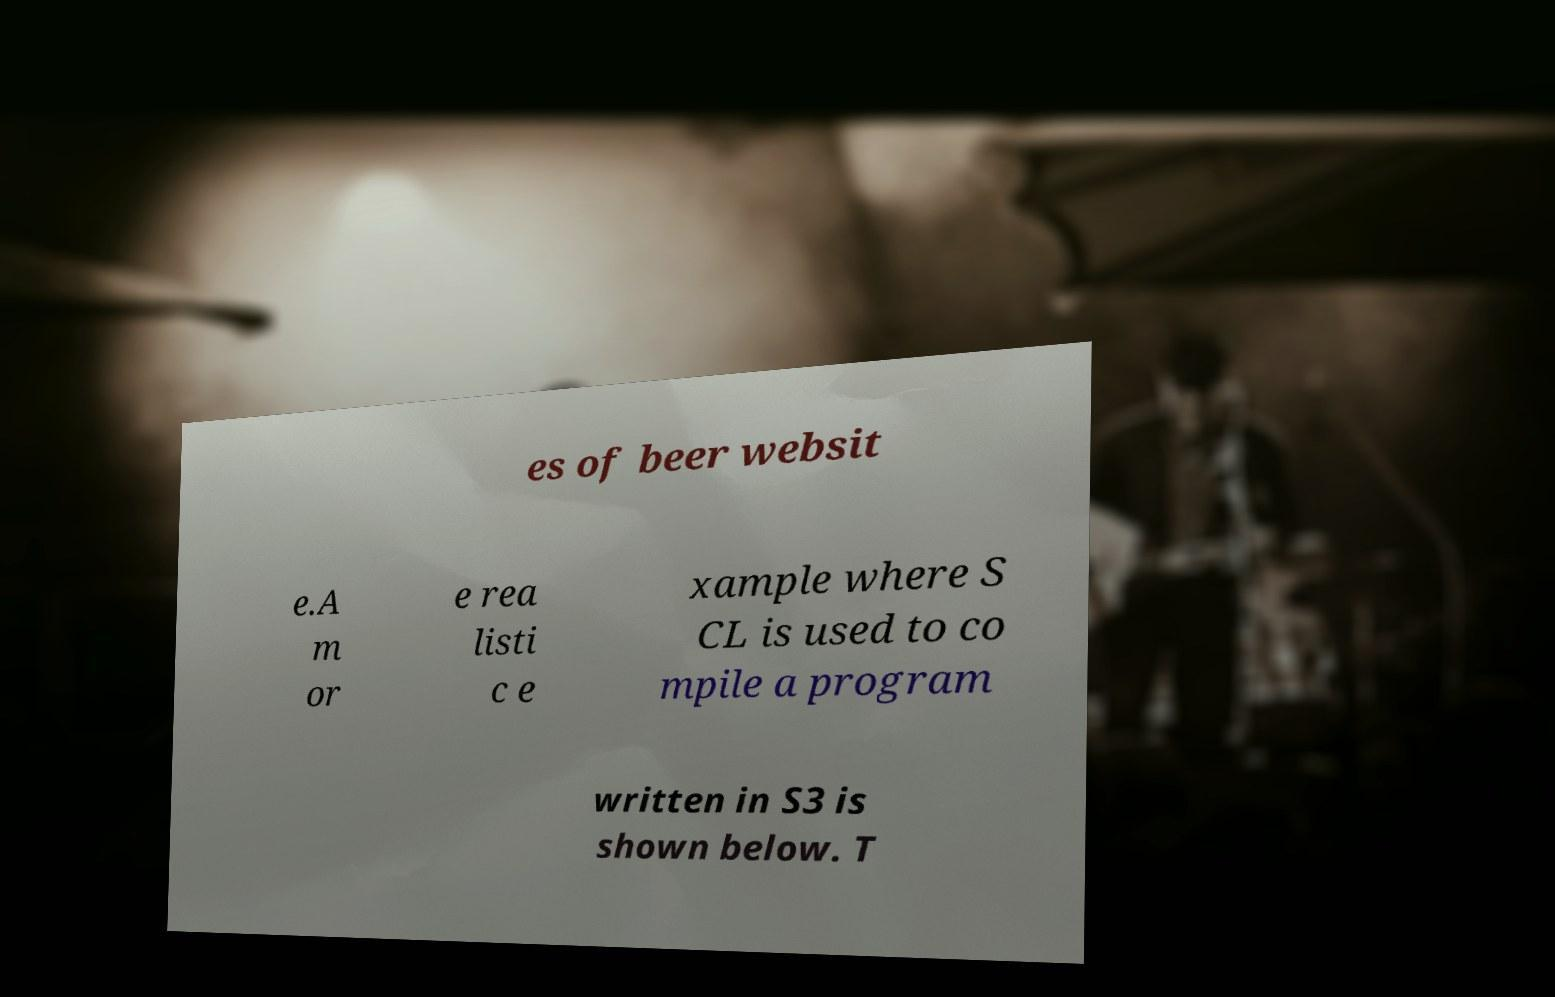What messages or text are displayed in this image? I need them in a readable, typed format. es of beer websit e.A m or e rea listi c e xample where S CL is used to co mpile a program written in S3 is shown below. T 